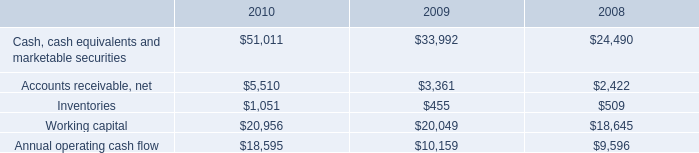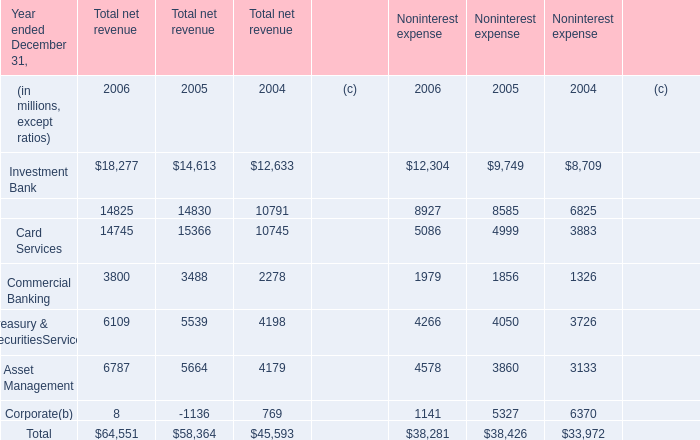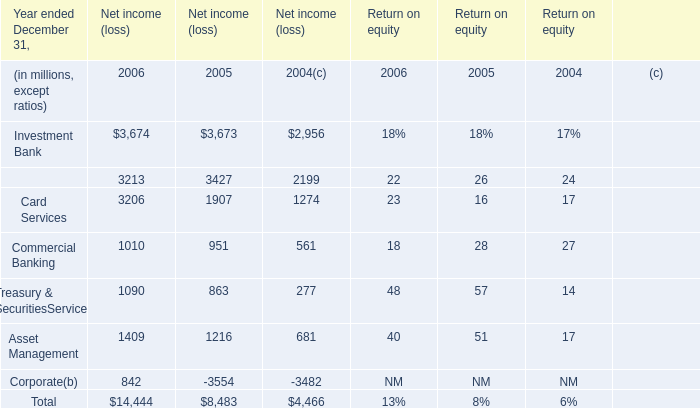What do all Total net revenue sum up without those Total net revenue smaller than 10000, in 2006? (in million) 
Computations: ((18277 + 14825) + 14745)
Answer: 47847.0. 